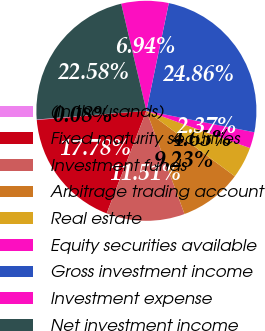Convert chart. <chart><loc_0><loc_0><loc_500><loc_500><pie_chart><fcel>(In thousands)<fcel>Fixed maturity securities<fcel>Investment funds<fcel>Arbitrage trading account<fcel>Real estate<fcel>Equity securities available<fcel>Gross investment income<fcel>Investment expense<fcel>Net investment income<nl><fcel>0.08%<fcel>17.78%<fcel>11.51%<fcel>9.23%<fcel>4.65%<fcel>2.37%<fcel>24.86%<fcel>6.94%<fcel>22.58%<nl></chart> 